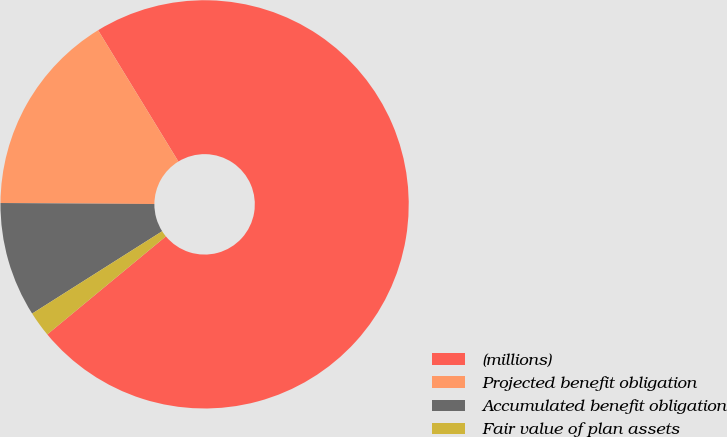Convert chart to OTSL. <chart><loc_0><loc_0><loc_500><loc_500><pie_chart><fcel>(millions)<fcel>Projected benefit obligation<fcel>Accumulated benefit obligation<fcel>Fair value of plan assets<nl><fcel>72.74%<fcel>16.16%<fcel>9.09%<fcel>2.01%<nl></chart> 